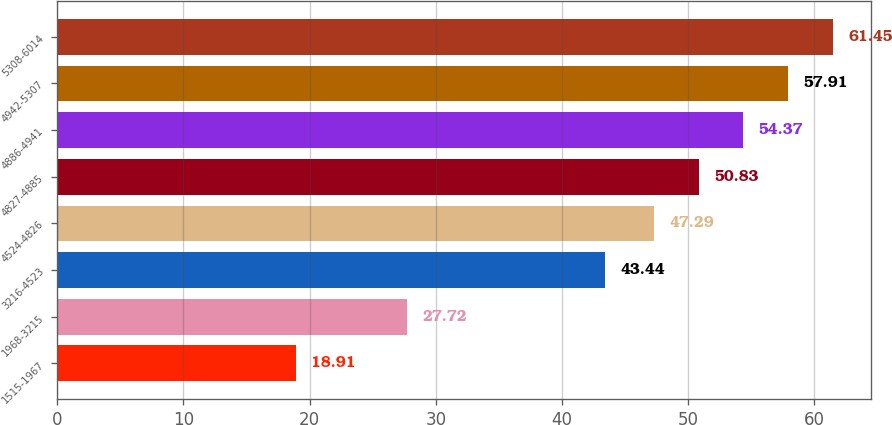Convert chart. <chart><loc_0><loc_0><loc_500><loc_500><bar_chart><fcel>1515-1967<fcel>1968-3215<fcel>3216-4523<fcel>4524-4826<fcel>4827-4885<fcel>4886-4941<fcel>4942-5307<fcel>5308-6014<nl><fcel>18.91<fcel>27.72<fcel>43.44<fcel>47.29<fcel>50.83<fcel>54.37<fcel>57.91<fcel>61.45<nl></chart> 